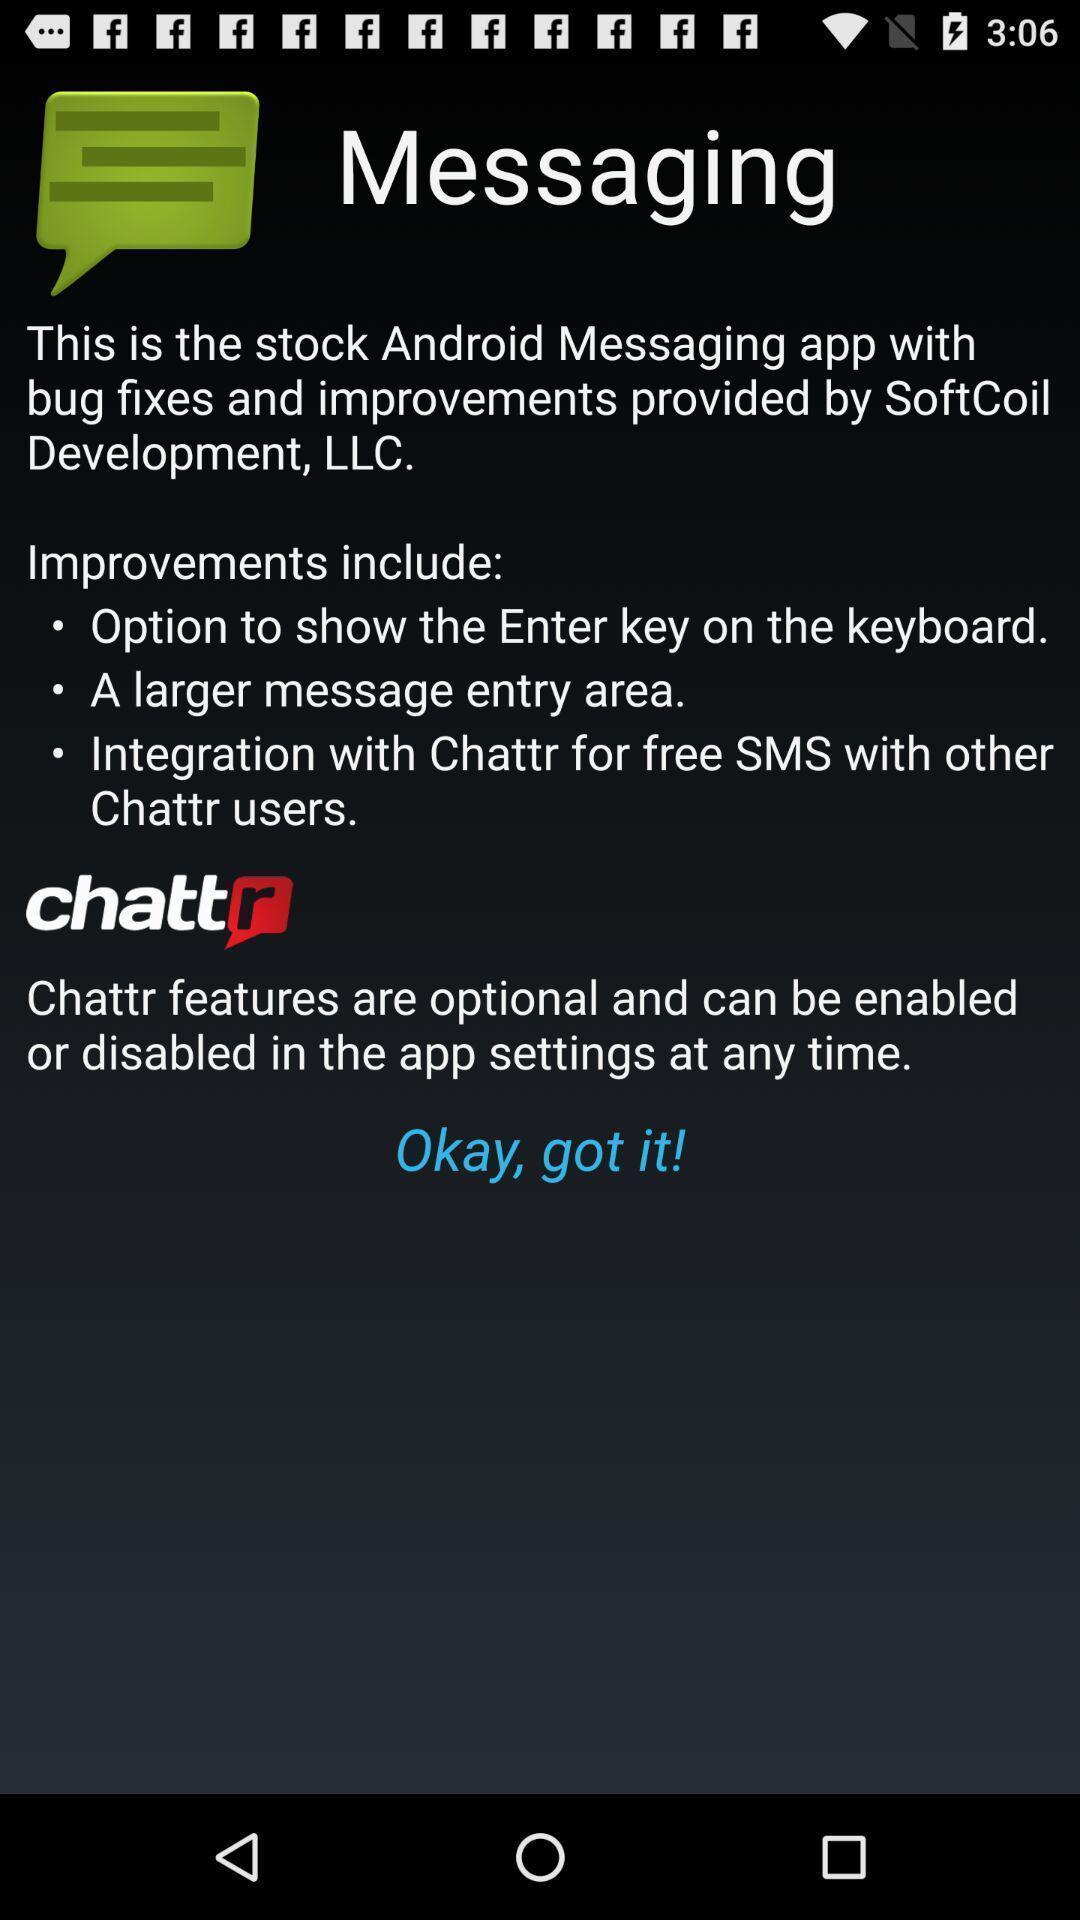Provide a detailed account of this screenshot. Page displaying the information about social app. 